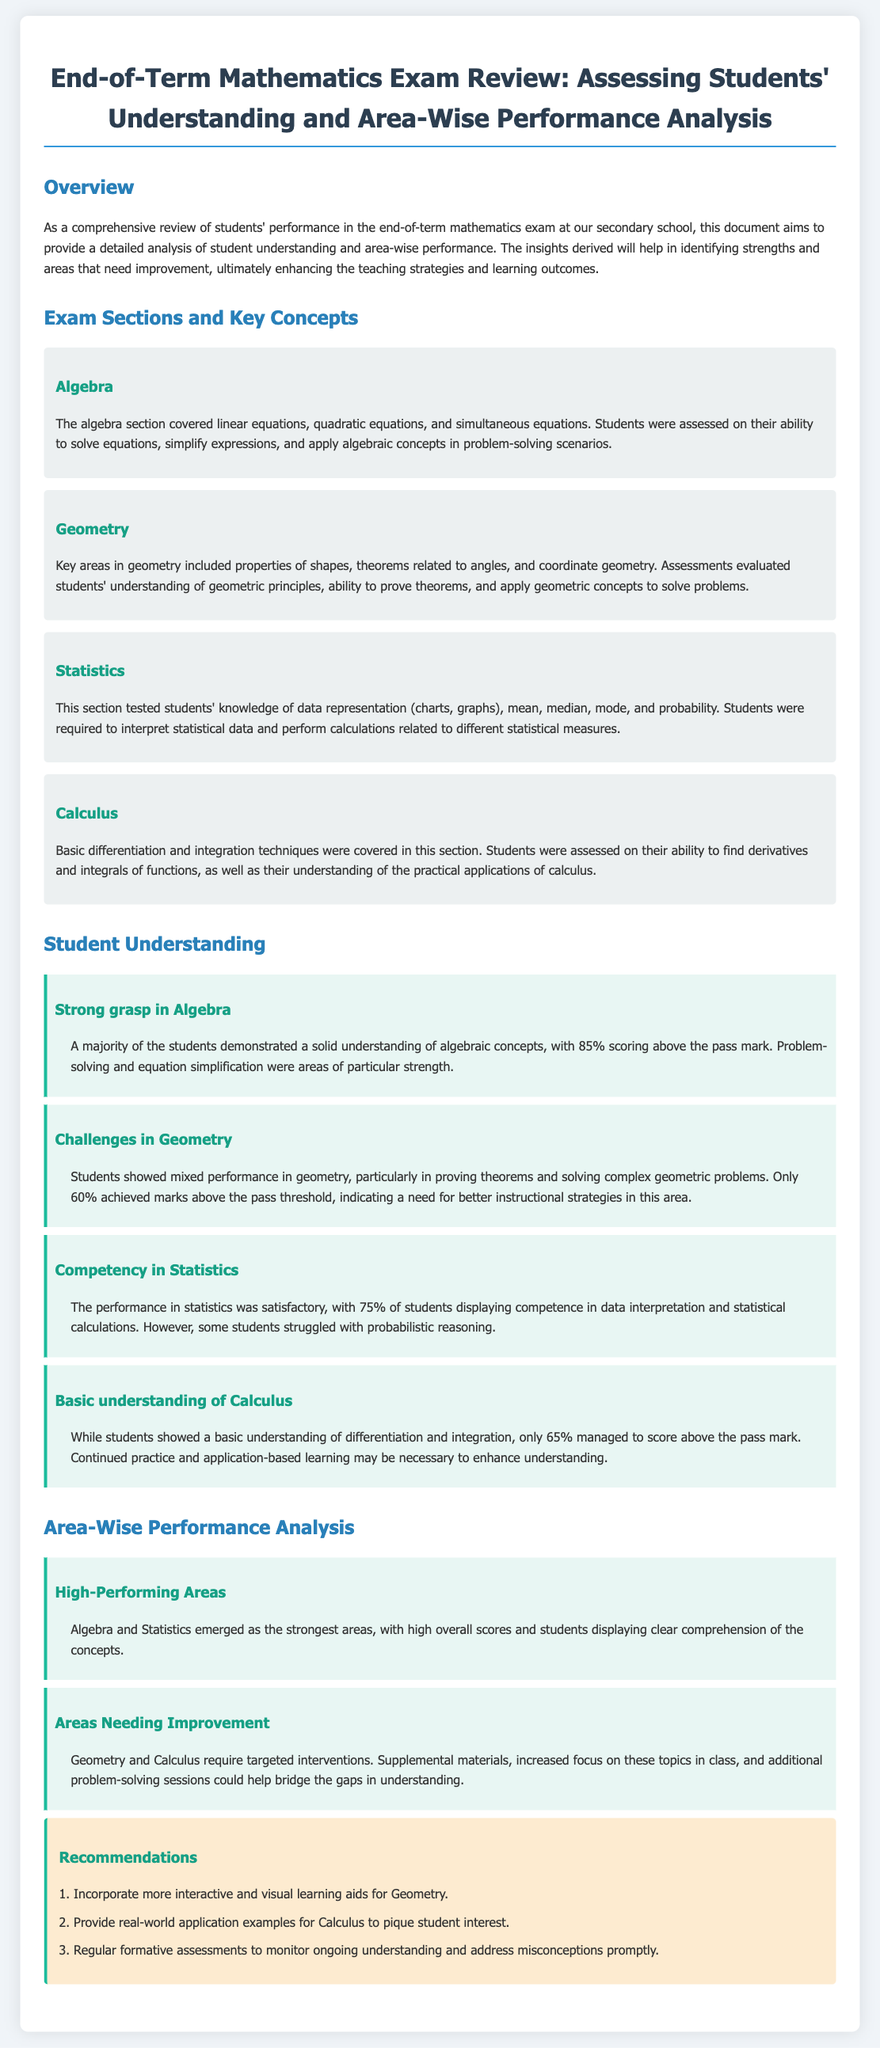What are the four main sections covered in the exam? The main sections listed are Algebra, Geometry, Statistics, and Calculus.
Answer: Algebra, Geometry, Statistics, Calculus What percentage of students scored above the pass mark in Algebra? The document states that 85% of students scored above the pass mark in Algebra.
Answer: 85% Which area had the lowest student performance based on the analysis? The document indicates that geometry had the lowest performance, with only 60% above the pass threshold.
Answer: Geometry What is recommended to enhance understanding of Calculus? One of the recommendations is to provide real-world application examples for Calculus.
Answer: Real-world application examples What percentage of students displayed competence in Statistics? According to the document, 75% of students displayed competence in statistics.
Answer: 75% 